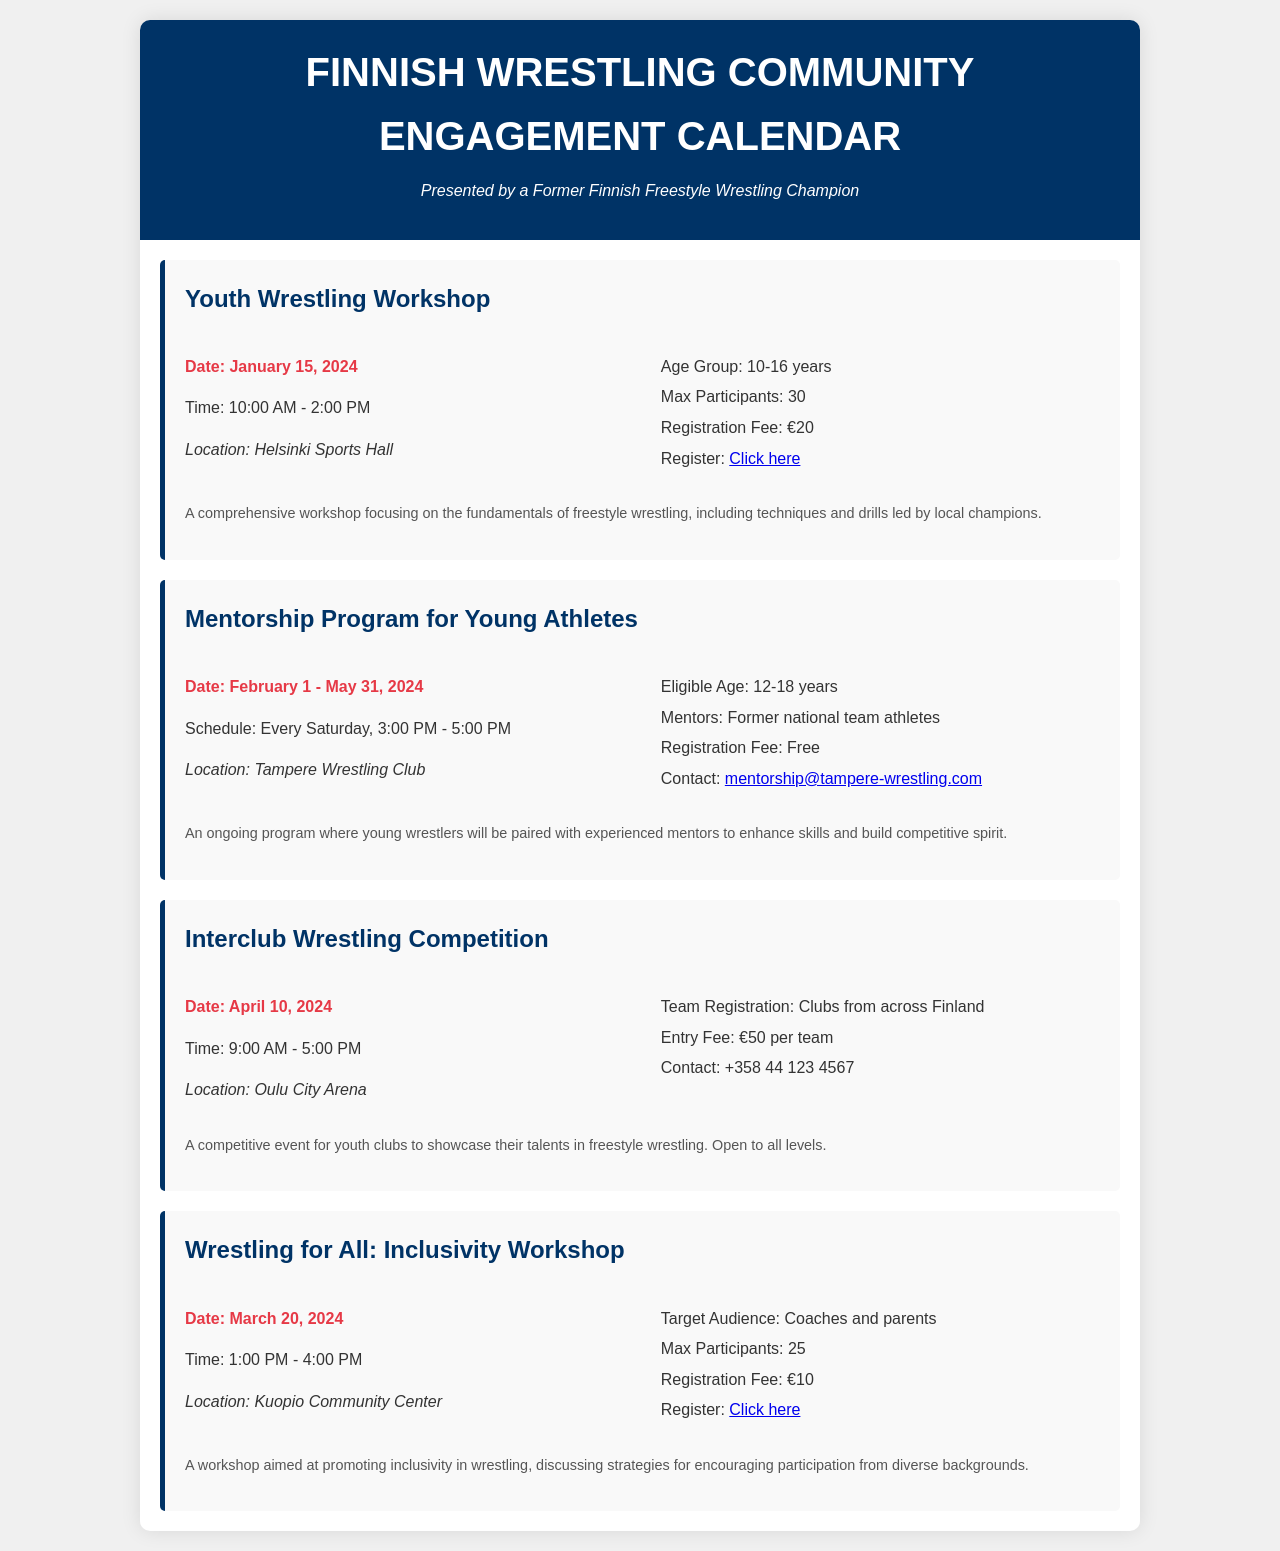What is the date of the Youth Wrestling Workshop? The date of the Youth Wrestling Workshop is specified in the document.
Answer: January 15, 2024 How many maximum participants are allowed for the Inclusivity Workshop? The maximum number of participants for the Inclusivity Workshop is stated.
Answer: 25 What is the registration fee for the Mentorship Program? The document mentions that the registration fee for the Mentorship Program is free.
Answer: Free When does the Mentorship Program start? The starting date of the Mentorship Program can be found in the document.
Answer: February 1, 2024 Where is the Interclub Wrestling Competition being held? The location for the Interclub Wrestling Competition is listed in the document.
Answer: Oulu City Arena Which age group is targeted for the Youth Wrestling Workshop? The target age group for the Youth Wrestling Workshop is indicated in the document.
Answer: 10-16 years What is the time for the Wrestling for All workshop? The document specifies the time for the Wrestling for All workshop.
Answer: 1:00 PM - 4:00 PM Who are the mentors in the Mentorship Program? The document states that the mentors in the Mentorship Program are former national team athletes.
Answer: Former national team athletes 